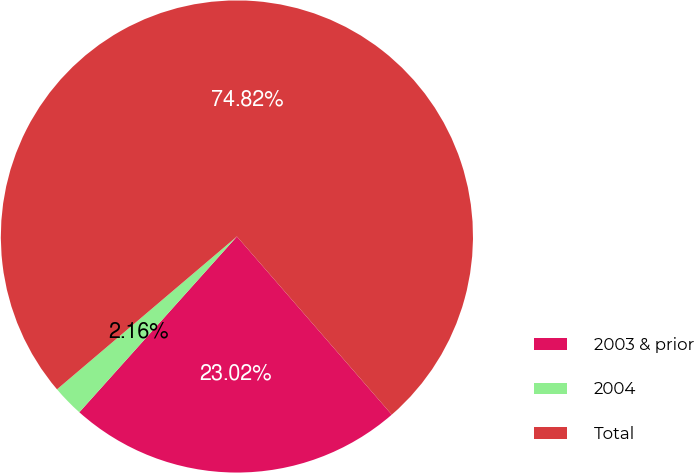Convert chart to OTSL. <chart><loc_0><loc_0><loc_500><loc_500><pie_chart><fcel>2003 & prior<fcel>2004<fcel>Total<nl><fcel>23.02%<fcel>2.16%<fcel>74.82%<nl></chart> 